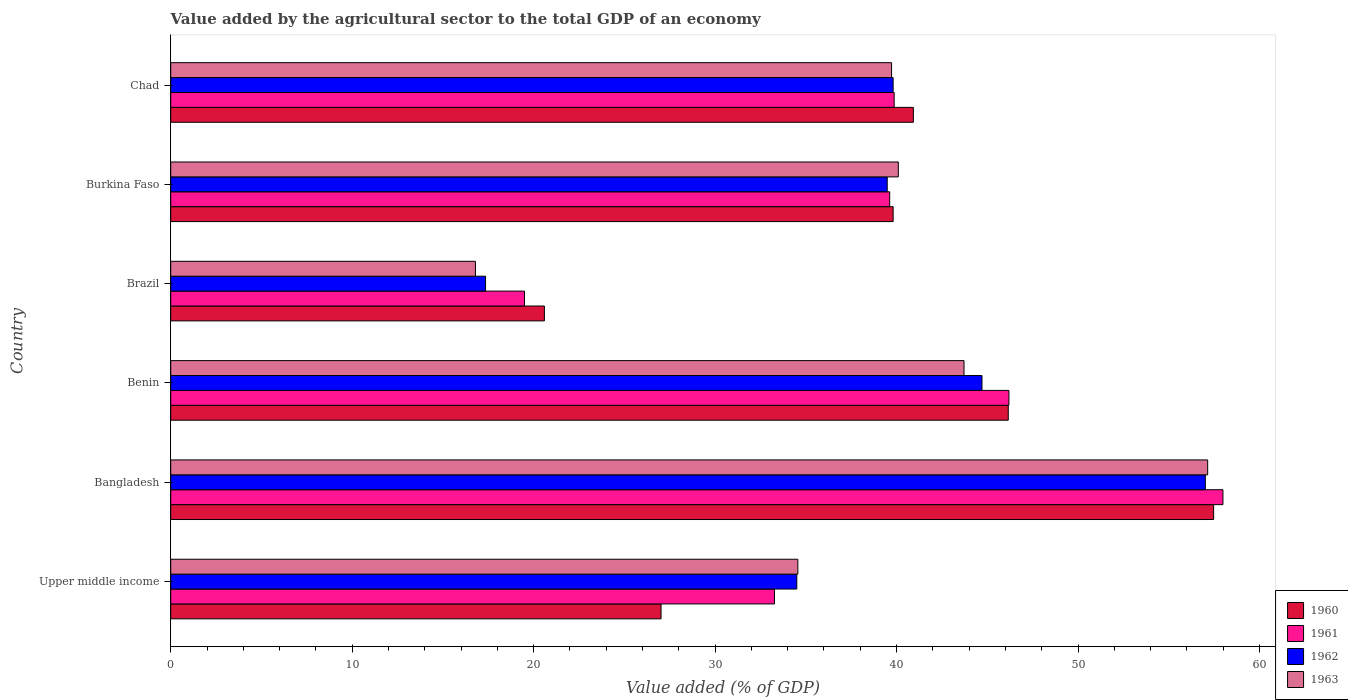How many different coloured bars are there?
Give a very brief answer. 4. How many groups of bars are there?
Your response must be concise. 6. Are the number of bars on each tick of the Y-axis equal?
Your answer should be compact. Yes. How many bars are there on the 5th tick from the top?
Offer a terse response. 4. What is the label of the 2nd group of bars from the top?
Ensure brevity in your answer.  Burkina Faso. What is the value added by the agricultural sector to the total GDP in 1963 in Brazil?
Ensure brevity in your answer.  16.79. Across all countries, what is the maximum value added by the agricultural sector to the total GDP in 1961?
Provide a short and direct response. 57.99. Across all countries, what is the minimum value added by the agricultural sector to the total GDP in 1962?
Offer a very short reply. 17.35. What is the total value added by the agricultural sector to the total GDP in 1961 in the graph?
Provide a short and direct response. 236.44. What is the difference between the value added by the agricultural sector to the total GDP in 1960 in Bangladesh and that in Brazil?
Make the answer very short. 36.88. What is the difference between the value added by the agricultural sector to the total GDP in 1960 in Chad and the value added by the agricultural sector to the total GDP in 1961 in Upper middle income?
Ensure brevity in your answer.  7.65. What is the average value added by the agricultural sector to the total GDP in 1962 per country?
Give a very brief answer. 38.81. What is the difference between the value added by the agricultural sector to the total GDP in 1960 and value added by the agricultural sector to the total GDP in 1962 in Upper middle income?
Make the answer very short. -7.48. What is the ratio of the value added by the agricultural sector to the total GDP in 1961 in Bangladesh to that in Upper middle income?
Offer a very short reply. 1.74. What is the difference between the highest and the second highest value added by the agricultural sector to the total GDP in 1962?
Your answer should be very brief. 12.31. What is the difference between the highest and the lowest value added by the agricultural sector to the total GDP in 1961?
Ensure brevity in your answer.  38.49. Is it the case that in every country, the sum of the value added by the agricultural sector to the total GDP in 1963 and value added by the agricultural sector to the total GDP in 1960 is greater than the sum of value added by the agricultural sector to the total GDP in 1962 and value added by the agricultural sector to the total GDP in 1961?
Provide a succinct answer. No. What does the 2nd bar from the bottom in Bangladesh represents?
Offer a terse response. 1961. Are all the bars in the graph horizontal?
Give a very brief answer. Yes. How many countries are there in the graph?
Your response must be concise. 6. Are the values on the major ticks of X-axis written in scientific E-notation?
Give a very brief answer. No. Does the graph contain grids?
Provide a short and direct response. No. How many legend labels are there?
Ensure brevity in your answer.  4. How are the legend labels stacked?
Provide a succinct answer. Vertical. What is the title of the graph?
Your answer should be very brief. Value added by the agricultural sector to the total GDP of an economy. Does "1970" appear as one of the legend labels in the graph?
Offer a terse response. No. What is the label or title of the X-axis?
Make the answer very short. Value added (% of GDP). What is the label or title of the Y-axis?
Your answer should be very brief. Country. What is the Value added (% of GDP) of 1960 in Upper middle income?
Your response must be concise. 27.02. What is the Value added (% of GDP) of 1961 in Upper middle income?
Provide a succinct answer. 33.27. What is the Value added (% of GDP) in 1962 in Upper middle income?
Ensure brevity in your answer.  34.5. What is the Value added (% of GDP) in 1963 in Upper middle income?
Offer a terse response. 34.56. What is the Value added (% of GDP) of 1960 in Bangladesh?
Give a very brief answer. 57.47. What is the Value added (% of GDP) of 1961 in Bangladesh?
Provide a succinct answer. 57.99. What is the Value added (% of GDP) in 1962 in Bangladesh?
Ensure brevity in your answer.  57.02. What is the Value added (% of GDP) in 1963 in Bangladesh?
Make the answer very short. 57.15. What is the Value added (% of GDP) in 1960 in Benin?
Provide a succinct answer. 46.16. What is the Value added (% of GDP) of 1961 in Benin?
Provide a succinct answer. 46.19. What is the Value added (% of GDP) in 1962 in Benin?
Your answer should be compact. 44.71. What is the Value added (% of GDP) of 1963 in Benin?
Provide a short and direct response. 43.72. What is the Value added (% of GDP) of 1960 in Brazil?
Give a very brief answer. 20.59. What is the Value added (% of GDP) of 1961 in Brazil?
Make the answer very short. 19.5. What is the Value added (% of GDP) in 1962 in Brazil?
Ensure brevity in your answer.  17.35. What is the Value added (% of GDP) in 1963 in Brazil?
Your answer should be compact. 16.79. What is the Value added (% of GDP) of 1960 in Burkina Faso?
Ensure brevity in your answer.  39.81. What is the Value added (% of GDP) in 1961 in Burkina Faso?
Your answer should be very brief. 39.62. What is the Value added (% of GDP) in 1962 in Burkina Faso?
Offer a very short reply. 39.49. What is the Value added (% of GDP) of 1963 in Burkina Faso?
Offer a very short reply. 40.1. What is the Value added (% of GDP) of 1960 in Chad?
Provide a short and direct response. 40.93. What is the Value added (% of GDP) in 1961 in Chad?
Provide a short and direct response. 39.87. What is the Value added (% of GDP) in 1962 in Chad?
Provide a succinct answer. 39.81. What is the Value added (% of GDP) in 1963 in Chad?
Offer a terse response. 39.73. Across all countries, what is the maximum Value added (% of GDP) in 1960?
Offer a very short reply. 57.47. Across all countries, what is the maximum Value added (% of GDP) in 1961?
Keep it short and to the point. 57.99. Across all countries, what is the maximum Value added (% of GDP) of 1962?
Make the answer very short. 57.02. Across all countries, what is the maximum Value added (% of GDP) of 1963?
Offer a terse response. 57.15. Across all countries, what is the minimum Value added (% of GDP) of 1960?
Provide a succinct answer. 20.59. Across all countries, what is the minimum Value added (% of GDP) of 1961?
Provide a short and direct response. 19.5. Across all countries, what is the minimum Value added (% of GDP) of 1962?
Give a very brief answer. 17.35. Across all countries, what is the minimum Value added (% of GDP) in 1963?
Make the answer very short. 16.79. What is the total Value added (% of GDP) of 1960 in the graph?
Make the answer very short. 231.99. What is the total Value added (% of GDP) in 1961 in the graph?
Offer a very short reply. 236.44. What is the total Value added (% of GDP) in 1962 in the graph?
Keep it short and to the point. 232.88. What is the total Value added (% of GDP) of 1963 in the graph?
Your response must be concise. 232.04. What is the difference between the Value added (% of GDP) in 1960 in Upper middle income and that in Bangladesh?
Ensure brevity in your answer.  -30.45. What is the difference between the Value added (% of GDP) in 1961 in Upper middle income and that in Bangladesh?
Your answer should be very brief. -24.71. What is the difference between the Value added (% of GDP) in 1962 in Upper middle income and that in Bangladesh?
Ensure brevity in your answer.  -22.51. What is the difference between the Value added (% of GDP) of 1963 in Upper middle income and that in Bangladesh?
Offer a terse response. -22.59. What is the difference between the Value added (% of GDP) of 1960 in Upper middle income and that in Benin?
Provide a short and direct response. -19.14. What is the difference between the Value added (% of GDP) in 1961 in Upper middle income and that in Benin?
Your answer should be very brief. -12.92. What is the difference between the Value added (% of GDP) in 1962 in Upper middle income and that in Benin?
Your answer should be compact. -10.21. What is the difference between the Value added (% of GDP) in 1963 in Upper middle income and that in Benin?
Your response must be concise. -9.16. What is the difference between the Value added (% of GDP) in 1960 in Upper middle income and that in Brazil?
Ensure brevity in your answer.  6.43. What is the difference between the Value added (% of GDP) of 1961 in Upper middle income and that in Brazil?
Ensure brevity in your answer.  13.78. What is the difference between the Value added (% of GDP) of 1962 in Upper middle income and that in Brazil?
Your response must be concise. 17.15. What is the difference between the Value added (% of GDP) of 1963 in Upper middle income and that in Brazil?
Offer a very short reply. 17.77. What is the difference between the Value added (% of GDP) in 1960 in Upper middle income and that in Burkina Faso?
Provide a succinct answer. -12.79. What is the difference between the Value added (% of GDP) in 1961 in Upper middle income and that in Burkina Faso?
Provide a short and direct response. -6.35. What is the difference between the Value added (% of GDP) in 1962 in Upper middle income and that in Burkina Faso?
Your answer should be very brief. -4.98. What is the difference between the Value added (% of GDP) of 1963 in Upper middle income and that in Burkina Faso?
Make the answer very short. -5.54. What is the difference between the Value added (% of GDP) in 1960 in Upper middle income and that in Chad?
Provide a succinct answer. -13.9. What is the difference between the Value added (% of GDP) of 1961 in Upper middle income and that in Chad?
Offer a very short reply. -6.59. What is the difference between the Value added (% of GDP) in 1962 in Upper middle income and that in Chad?
Ensure brevity in your answer.  -5.31. What is the difference between the Value added (% of GDP) in 1963 in Upper middle income and that in Chad?
Provide a short and direct response. -5.17. What is the difference between the Value added (% of GDP) of 1960 in Bangladesh and that in Benin?
Give a very brief answer. 11.32. What is the difference between the Value added (% of GDP) in 1961 in Bangladesh and that in Benin?
Ensure brevity in your answer.  11.79. What is the difference between the Value added (% of GDP) in 1962 in Bangladesh and that in Benin?
Offer a very short reply. 12.31. What is the difference between the Value added (% of GDP) of 1963 in Bangladesh and that in Benin?
Provide a succinct answer. 13.43. What is the difference between the Value added (% of GDP) of 1960 in Bangladesh and that in Brazil?
Provide a short and direct response. 36.88. What is the difference between the Value added (% of GDP) of 1961 in Bangladesh and that in Brazil?
Your answer should be very brief. 38.49. What is the difference between the Value added (% of GDP) in 1962 in Bangladesh and that in Brazil?
Keep it short and to the point. 39.67. What is the difference between the Value added (% of GDP) in 1963 in Bangladesh and that in Brazil?
Offer a very short reply. 40.35. What is the difference between the Value added (% of GDP) in 1960 in Bangladesh and that in Burkina Faso?
Your answer should be compact. 17.66. What is the difference between the Value added (% of GDP) in 1961 in Bangladesh and that in Burkina Faso?
Ensure brevity in your answer.  18.37. What is the difference between the Value added (% of GDP) of 1962 in Bangladesh and that in Burkina Faso?
Your answer should be compact. 17.53. What is the difference between the Value added (% of GDP) in 1963 in Bangladesh and that in Burkina Faso?
Your answer should be very brief. 17.05. What is the difference between the Value added (% of GDP) in 1960 in Bangladesh and that in Chad?
Keep it short and to the point. 16.55. What is the difference between the Value added (% of GDP) of 1961 in Bangladesh and that in Chad?
Keep it short and to the point. 18.12. What is the difference between the Value added (% of GDP) in 1962 in Bangladesh and that in Chad?
Keep it short and to the point. 17.21. What is the difference between the Value added (% of GDP) of 1963 in Bangladesh and that in Chad?
Offer a terse response. 17.42. What is the difference between the Value added (% of GDP) of 1960 in Benin and that in Brazil?
Ensure brevity in your answer.  25.56. What is the difference between the Value added (% of GDP) of 1961 in Benin and that in Brazil?
Your response must be concise. 26.7. What is the difference between the Value added (% of GDP) in 1962 in Benin and that in Brazil?
Offer a very short reply. 27.36. What is the difference between the Value added (% of GDP) of 1963 in Benin and that in Brazil?
Your response must be concise. 26.92. What is the difference between the Value added (% of GDP) in 1960 in Benin and that in Burkina Faso?
Your answer should be compact. 6.35. What is the difference between the Value added (% of GDP) of 1961 in Benin and that in Burkina Faso?
Offer a very short reply. 6.57. What is the difference between the Value added (% of GDP) of 1962 in Benin and that in Burkina Faso?
Make the answer very short. 5.22. What is the difference between the Value added (% of GDP) of 1963 in Benin and that in Burkina Faso?
Your answer should be very brief. 3.62. What is the difference between the Value added (% of GDP) in 1960 in Benin and that in Chad?
Offer a terse response. 5.23. What is the difference between the Value added (% of GDP) of 1961 in Benin and that in Chad?
Keep it short and to the point. 6.33. What is the difference between the Value added (% of GDP) in 1962 in Benin and that in Chad?
Provide a short and direct response. 4.9. What is the difference between the Value added (% of GDP) of 1963 in Benin and that in Chad?
Provide a short and direct response. 3.99. What is the difference between the Value added (% of GDP) in 1960 in Brazil and that in Burkina Faso?
Your answer should be very brief. -19.22. What is the difference between the Value added (% of GDP) of 1961 in Brazil and that in Burkina Faso?
Provide a succinct answer. -20.13. What is the difference between the Value added (% of GDP) in 1962 in Brazil and that in Burkina Faso?
Give a very brief answer. -22.14. What is the difference between the Value added (% of GDP) of 1963 in Brazil and that in Burkina Faso?
Give a very brief answer. -23.3. What is the difference between the Value added (% of GDP) of 1960 in Brazil and that in Chad?
Offer a very short reply. -20.33. What is the difference between the Value added (% of GDP) in 1961 in Brazil and that in Chad?
Provide a short and direct response. -20.37. What is the difference between the Value added (% of GDP) in 1962 in Brazil and that in Chad?
Offer a very short reply. -22.46. What is the difference between the Value added (% of GDP) of 1963 in Brazil and that in Chad?
Give a very brief answer. -22.93. What is the difference between the Value added (% of GDP) in 1960 in Burkina Faso and that in Chad?
Provide a short and direct response. -1.11. What is the difference between the Value added (% of GDP) of 1961 in Burkina Faso and that in Chad?
Your answer should be very brief. -0.25. What is the difference between the Value added (% of GDP) of 1962 in Burkina Faso and that in Chad?
Ensure brevity in your answer.  -0.33. What is the difference between the Value added (% of GDP) in 1963 in Burkina Faso and that in Chad?
Ensure brevity in your answer.  0.37. What is the difference between the Value added (% of GDP) in 1960 in Upper middle income and the Value added (% of GDP) in 1961 in Bangladesh?
Offer a very short reply. -30.97. What is the difference between the Value added (% of GDP) in 1960 in Upper middle income and the Value added (% of GDP) in 1962 in Bangladesh?
Make the answer very short. -30. What is the difference between the Value added (% of GDP) in 1960 in Upper middle income and the Value added (% of GDP) in 1963 in Bangladesh?
Your response must be concise. -30.12. What is the difference between the Value added (% of GDP) in 1961 in Upper middle income and the Value added (% of GDP) in 1962 in Bangladesh?
Keep it short and to the point. -23.74. What is the difference between the Value added (% of GDP) in 1961 in Upper middle income and the Value added (% of GDP) in 1963 in Bangladesh?
Your response must be concise. -23.87. What is the difference between the Value added (% of GDP) of 1962 in Upper middle income and the Value added (% of GDP) of 1963 in Bangladesh?
Provide a succinct answer. -22.64. What is the difference between the Value added (% of GDP) of 1960 in Upper middle income and the Value added (% of GDP) of 1961 in Benin?
Your response must be concise. -19.17. What is the difference between the Value added (% of GDP) of 1960 in Upper middle income and the Value added (% of GDP) of 1962 in Benin?
Your response must be concise. -17.69. What is the difference between the Value added (% of GDP) in 1960 in Upper middle income and the Value added (% of GDP) in 1963 in Benin?
Your answer should be compact. -16.7. What is the difference between the Value added (% of GDP) of 1961 in Upper middle income and the Value added (% of GDP) of 1962 in Benin?
Offer a very short reply. -11.43. What is the difference between the Value added (% of GDP) in 1961 in Upper middle income and the Value added (% of GDP) in 1963 in Benin?
Provide a short and direct response. -10.44. What is the difference between the Value added (% of GDP) in 1962 in Upper middle income and the Value added (% of GDP) in 1963 in Benin?
Give a very brief answer. -9.21. What is the difference between the Value added (% of GDP) in 1960 in Upper middle income and the Value added (% of GDP) in 1961 in Brazil?
Provide a succinct answer. 7.53. What is the difference between the Value added (% of GDP) of 1960 in Upper middle income and the Value added (% of GDP) of 1962 in Brazil?
Ensure brevity in your answer.  9.67. What is the difference between the Value added (% of GDP) in 1960 in Upper middle income and the Value added (% of GDP) in 1963 in Brazil?
Keep it short and to the point. 10.23. What is the difference between the Value added (% of GDP) of 1961 in Upper middle income and the Value added (% of GDP) of 1962 in Brazil?
Offer a very short reply. 15.92. What is the difference between the Value added (% of GDP) in 1961 in Upper middle income and the Value added (% of GDP) in 1963 in Brazil?
Give a very brief answer. 16.48. What is the difference between the Value added (% of GDP) in 1962 in Upper middle income and the Value added (% of GDP) in 1963 in Brazil?
Give a very brief answer. 17.71. What is the difference between the Value added (% of GDP) of 1960 in Upper middle income and the Value added (% of GDP) of 1961 in Burkina Faso?
Your answer should be very brief. -12.6. What is the difference between the Value added (% of GDP) of 1960 in Upper middle income and the Value added (% of GDP) of 1962 in Burkina Faso?
Provide a short and direct response. -12.46. What is the difference between the Value added (% of GDP) in 1960 in Upper middle income and the Value added (% of GDP) in 1963 in Burkina Faso?
Provide a succinct answer. -13.08. What is the difference between the Value added (% of GDP) in 1961 in Upper middle income and the Value added (% of GDP) in 1962 in Burkina Faso?
Your answer should be very brief. -6.21. What is the difference between the Value added (% of GDP) of 1961 in Upper middle income and the Value added (% of GDP) of 1963 in Burkina Faso?
Give a very brief answer. -6.82. What is the difference between the Value added (% of GDP) of 1962 in Upper middle income and the Value added (% of GDP) of 1963 in Burkina Faso?
Offer a very short reply. -5.59. What is the difference between the Value added (% of GDP) in 1960 in Upper middle income and the Value added (% of GDP) in 1961 in Chad?
Ensure brevity in your answer.  -12.85. What is the difference between the Value added (% of GDP) of 1960 in Upper middle income and the Value added (% of GDP) of 1962 in Chad?
Provide a succinct answer. -12.79. What is the difference between the Value added (% of GDP) in 1960 in Upper middle income and the Value added (% of GDP) in 1963 in Chad?
Provide a short and direct response. -12.7. What is the difference between the Value added (% of GDP) of 1961 in Upper middle income and the Value added (% of GDP) of 1962 in Chad?
Your response must be concise. -6.54. What is the difference between the Value added (% of GDP) of 1961 in Upper middle income and the Value added (% of GDP) of 1963 in Chad?
Provide a succinct answer. -6.45. What is the difference between the Value added (% of GDP) of 1962 in Upper middle income and the Value added (% of GDP) of 1963 in Chad?
Ensure brevity in your answer.  -5.22. What is the difference between the Value added (% of GDP) of 1960 in Bangladesh and the Value added (% of GDP) of 1961 in Benin?
Offer a terse response. 11.28. What is the difference between the Value added (% of GDP) in 1960 in Bangladesh and the Value added (% of GDP) in 1962 in Benin?
Your response must be concise. 12.77. What is the difference between the Value added (% of GDP) of 1960 in Bangladesh and the Value added (% of GDP) of 1963 in Benin?
Make the answer very short. 13.76. What is the difference between the Value added (% of GDP) of 1961 in Bangladesh and the Value added (% of GDP) of 1962 in Benin?
Your response must be concise. 13.28. What is the difference between the Value added (% of GDP) in 1961 in Bangladesh and the Value added (% of GDP) in 1963 in Benin?
Keep it short and to the point. 14.27. What is the difference between the Value added (% of GDP) in 1962 in Bangladesh and the Value added (% of GDP) in 1963 in Benin?
Offer a terse response. 13.3. What is the difference between the Value added (% of GDP) of 1960 in Bangladesh and the Value added (% of GDP) of 1961 in Brazil?
Give a very brief answer. 37.98. What is the difference between the Value added (% of GDP) of 1960 in Bangladesh and the Value added (% of GDP) of 1962 in Brazil?
Offer a terse response. 40.12. What is the difference between the Value added (% of GDP) in 1960 in Bangladesh and the Value added (% of GDP) in 1963 in Brazil?
Ensure brevity in your answer.  40.68. What is the difference between the Value added (% of GDP) of 1961 in Bangladesh and the Value added (% of GDP) of 1962 in Brazil?
Your response must be concise. 40.64. What is the difference between the Value added (% of GDP) in 1961 in Bangladesh and the Value added (% of GDP) in 1963 in Brazil?
Your response must be concise. 41.19. What is the difference between the Value added (% of GDP) of 1962 in Bangladesh and the Value added (% of GDP) of 1963 in Brazil?
Give a very brief answer. 40.22. What is the difference between the Value added (% of GDP) of 1960 in Bangladesh and the Value added (% of GDP) of 1961 in Burkina Faso?
Your answer should be compact. 17.85. What is the difference between the Value added (% of GDP) in 1960 in Bangladesh and the Value added (% of GDP) in 1962 in Burkina Faso?
Offer a very short reply. 17.99. What is the difference between the Value added (% of GDP) of 1960 in Bangladesh and the Value added (% of GDP) of 1963 in Burkina Faso?
Give a very brief answer. 17.38. What is the difference between the Value added (% of GDP) in 1961 in Bangladesh and the Value added (% of GDP) in 1962 in Burkina Faso?
Offer a very short reply. 18.5. What is the difference between the Value added (% of GDP) in 1961 in Bangladesh and the Value added (% of GDP) in 1963 in Burkina Faso?
Your answer should be very brief. 17.89. What is the difference between the Value added (% of GDP) of 1962 in Bangladesh and the Value added (% of GDP) of 1963 in Burkina Faso?
Make the answer very short. 16.92. What is the difference between the Value added (% of GDP) of 1960 in Bangladesh and the Value added (% of GDP) of 1961 in Chad?
Make the answer very short. 17.61. What is the difference between the Value added (% of GDP) of 1960 in Bangladesh and the Value added (% of GDP) of 1962 in Chad?
Offer a very short reply. 17.66. What is the difference between the Value added (% of GDP) in 1960 in Bangladesh and the Value added (% of GDP) in 1963 in Chad?
Offer a terse response. 17.75. What is the difference between the Value added (% of GDP) in 1961 in Bangladesh and the Value added (% of GDP) in 1962 in Chad?
Offer a very short reply. 18.18. What is the difference between the Value added (% of GDP) of 1961 in Bangladesh and the Value added (% of GDP) of 1963 in Chad?
Provide a short and direct response. 18.26. What is the difference between the Value added (% of GDP) in 1962 in Bangladesh and the Value added (% of GDP) in 1963 in Chad?
Make the answer very short. 17.29. What is the difference between the Value added (% of GDP) in 1960 in Benin and the Value added (% of GDP) in 1961 in Brazil?
Offer a terse response. 26.66. What is the difference between the Value added (% of GDP) of 1960 in Benin and the Value added (% of GDP) of 1962 in Brazil?
Provide a succinct answer. 28.81. What is the difference between the Value added (% of GDP) in 1960 in Benin and the Value added (% of GDP) in 1963 in Brazil?
Ensure brevity in your answer.  29.36. What is the difference between the Value added (% of GDP) in 1961 in Benin and the Value added (% of GDP) in 1962 in Brazil?
Offer a terse response. 28.84. What is the difference between the Value added (% of GDP) in 1961 in Benin and the Value added (% of GDP) in 1963 in Brazil?
Offer a very short reply. 29.4. What is the difference between the Value added (% of GDP) in 1962 in Benin and the Value added (% of GDP) in 1963 in Brazil?
Your answer should be very brief. 27.92. What is the difference between the Value added (% of GDP) in 1960 in Benin and the Value added (% of GDP) in 1961 in Burkina Faso?
Your answer should be very brief. 6.54. What is the difference between the Value added (% of GDP) in 1960 in Benin and the Value added (% of GDP) in 1962 in Burkina Faso?
Make the answer very short. 6.67. What is the difference between the Value added (% of GDP) of 1960 in Benin and the Value added (% of GDP) of 1963 in Burkina Faso?
Ensure brevity in your answer.  6.06. What is the difference between the Value added (% of GDP) of 1961 in Benin and the Value added (% of GDP) of 1962 in Burkina Faso?
Provide a succinct answer. 6.71. What is the difference between the Value added (% of GDP) of 1961 in Benin and the Value added (% of GDP) of 1963 in Burkina Faso?
Keep it short and to the point. 6.1. What is the difference between the Value added (% of GDP) of 1962 in Benin and the Value added (% of GDP) of 1963 in Burkina Faso?
Give a very brief answer. 4.61. What is the difference between the Value added (% of GDP) in 1960 in Benin and the Value added (% of GDP) in 1961 in Chad?
Your response must be concise. 6.29. What is the difference between the Value added (% of GDP) in 1960 in Benin and the Value added (% of GDP) in 1962 in Chad?
Your answer should be very brief. 6.35. What is the difference between the Value added (% of GDP) of 1960 in Benin and the Value added (% of GDP) of 1963 in Chad?
Your response must be concise. 6.43. What is the difference between the Value added (% of GDP) in 1961 in Benin and the Value added (% of GDP) in 1962 in Chad?
Your answer should be very brief. 6.38. What is the difference between the Value added (% of GDP) in 1961 in Benin and the Value added (% of GDP) in 1963 in Chad?
Provide a short and direct response. 6.47. What is the difference between the Value added (% of GDP) in 1962 in Benin and the Value added (% of GDP) in 1963 in Chad?
Keep it short and to the point. 4.98. What is the difference between the Value added (% of GDP) in 1960 in Brazil and the Value added (% of GDP) in 1961 in Burkina Faso?
Provide a short and direct response. -19.03. What is the difference between the Value added (% of GDP) of 1960 in Brazil and the Value added (% of GDP) of 1962 in Burkina Faso?
Keep it short and to the point. -18.89. What is the difference between the Value added (% of GDP) of 1960 in Brazil and the Value added (% of GDP) of 1963 in Burkina Faso?
Provide a short and direct response. -19.51. What is the difference between the Value added (% of GDP) of 1961 in Brazil and the Value added (% of GDP) of 1962 in Burkina Faso?
Your answer should be compact. -19.99. What is the difference between the Value added (% of GDP) of 1961 in Brazil and the Value added (% of GDP) of 1963 in Burkina Faso?
Offer a very short reply. -20.6. What is the difference between the Value added (% of GDP) in 1962 in Brazil and the Value added (% of GDP) in 1963 in Burkina Faso?
Provide a succinct answer. -22.75. What is the difference between the Value added (% of GDP) of 1960 in Brazil and the Value added (% of GDP) of 1961 in Chad?
Your response must be concise. -19.28. What is the difference between the Value added (% of GDP) in 1960 in Brazil and the Value added (% of GDP) in 1962 in Chad?
Provide a succinct answer. -19.22. What is the difference between the Value added (% of GDP) of 1960 in Brazil and the Value added (% of GDP) of 1963 in Chad?
Your response must be concise. -19.13. What is the difference between the Value added (% of GDP) in 1961 in Brazil and the Value added (% of GDP) in 1962 in Chad?
Ensure brevity in your answer.  -20.32. What is the difference between the Value added (% of GDP) in 1961 in Brazil and the Value added (% of GDP) in 1963 in Chad?
Your response must be concise. -20.23. What is the difference between the Value added (% of GDP) of 1962 in Brazil and the Value added (% of GDP) of 1963 in Chad?
Provide a succinct answer. -22.38. What is the difference between the Value added (% of GDP) in 1960 in Burkina Faso and the Value added (% of GDP) in 1961 in Chad?
Give a very brief answer. -0.06. What is the difference between the Value added (% of GDP) of 1960 in Burkina Faso and the Value added (% of GDP) of 1963 in Chad?
Give a very brief answer. 0.09. What is the difference between the Value added (% of GDP) of 1961 in Burkina Faso and the Value added (% of GDP) of 1962 in Chad?
Ensure brevity in your answer.  -0.19. What is the difference between the Value added (% of GDP) in 1961 in Burkina Faso and the Value added (% of GDP) in 1963 in Chad?
Provide a succinct answer. -0.1. What is the difference between the Value added (% of GDP) of 1962 in Burkina Faso and the Value added (% of GDP) of 1963 in Chad?
Ensure brevity in your answer.  -0.24. What is the average Value added (% of GDP) of 1960 per country?
Keep it short and to the point. 38.66. What is the average Value added (% of GDP) in 1961 per country?
Provide a short and direct response. 39.41. What is the average Value added (% of GDP) in 1962 per country?
Ensure brevity in your answer.  38.81. What is the average Value added (% of GDP) in 1963 per country?
Provide a short and direct response. 38.67. What is the difference between the Value added (% of GDP) in 1960 and Value added (% of GDP) in 1961 in Upper middle income?
Your answer should be very brief. -6.25. What is the difference between the Value added (% of GDP) of 1960 and Value added (% of GDP) of 1962 in Upper middle income?
Give a very brief answer. -7.48. What is the difference between the Value added (% of GDP) of 1960 and Value added (% of GDP) of 1963 in Upper middle income?
Make the answer very short. -7.54. What is the difference between the Value added (% of GDP) in 1961 and Value added (% of GDP) in 1962 in Upper middle income?
Your answer should be very brief. -1.23. What is the difference between the Value added (% of GDP) in 1961 and Value added (% of GDP) in 1963 in Upper middle income?
Make the answer very short. -1.29. What is the difference between the Value added (% of GDP) in 1962 and Value added (% of GDP) in 1963 in Upper middle income?
Give a very brief answer. -0.06. What is the difference between the Value added (% of GDP) of 1960 and Value added (% of GDP) of 1961 in Bangladesh?
Your answer should be compact. -0.51. What is the difference between the Value added (% of GDP) of 1960 and Value added (% of GDP) of 1962 in Bangladesh?
Your answer should be very brief. 0.46. What is the difference between the Value added (% of GDP) of 1960 and Value added (% of GDP) of 1963 in Bangladesh?
Keep it short and to the point. 0.33. What is the difference between the Value added (% of GDP) in 1961 and Value added (% of GDP) in 1962 in Bangladesh?
Give a very brief answer. 0.97. What is the difference between the Value added (% of GDP) of 1961 and Value added (% of GDP) of 1963 in Bangladesh?
Provide a succinct answer. 0.84. What is the difference between the Value added (% of GDP) of 1962 and Value added (% of GDP) of 1963 in Bangladesh?
Provide a short and direct response. -0.13. What is the difference between the Value added (% of GDP) in 1960 and Value added (% of GDP) in 1961 in Benin?
Make the answer very short. -0.04. What is the difference between the Value added (% of GDP) of 1960 and Value added (% of GDP) of 1962 in Benin?
Your answer should be very brief. 1.45. What is the difference between the Value added (% of GDP) in 1960 and Value added (% of GDP) in 1963 in Benin?
Your response must be concise. 2.44. What is the difference between the Value added (% of GDP) of 1961 and Value added (% of GDP) of 1962 in Benin?
Your answer should be compact. 1.48. What is the difference between the Value added (% of GDP) in 1961 and Value added (% of GDP) in 1963 in Benin?
Make the answer very short. 2.48. What is the difference between the Value added (% of GDP) in 1962 and Value added (% of GDP) in 1963 in Benin?
Keep it short and to the point. 0.99. What is the difference between the Value added (% of GDP) in 1960 and Value added (% of GDP) in 1961 in Brazil?
Your answer should be compact. 1.1. What is the difference between the Value added (% of GDP) of 1960 and Value added (% of GDP) of 1962 in Brazil?
Ensure brevity in your answer.  3.24. What is the difference between the Value added (% of GDP) in 1960 and Value added (% of GDP) in 1963 in Brazil?
Your answer should be very brief. 3.8. What is the difference between the Value added (% of GDP) of 1961 and Value added (% of GDP) of 1962 in Brazil?
Offer a terse response. 2.15. What is the difference between the Value added (% of GDP) in 1961 and Value added (% of GDP) in 1963 in Brazil?
Offer a very short reply. 2.7. What is the difference between the Value added (% of GDP) of 1962 and Value added (% of GDP) of 1963 in Brazil?
Keep it short and to the point. 0.56. What is the difference between the Value added (% of GDP) of 1960 and Value added (% of GDP) of 1961 in Burkina Faso?
Your response must be concise. 0.19. What is the difference between the Value added (% of GDP) of 1960 and Value added (% of GDP) of 1962 in Burkina Faso?
Provide a succinct answer. 0.33. What is the difference between the Value added (% of GDP) in 1960 and Value added (% of GDP) in 1963 in Burkina Faso?
Make the answer very short. -0.29. What is the difference between the Value added (% of GDP) of 1961 and Value added (% of GDP) of 1962 in Burkina Faso?
Offer a terse response. 0.14. What is the difference between the Value added (% of GDP) in 1961 and Value added (% of GDP) in 1963 in Burkina Faso?
Ensure brevity in your answer.  -0.48. What is the difference between the Value added (% of GDP) of 1962 and Value added (% of GDP) of 1963 in Burkina Faso?
Offer a terse response. -0.61. What is the difference between the Value added (% of GDP) of 1960 and Value added (% of GDP) of 1961 in Chad?
Provide a short and direct response. 1.06. What is the difference between the Value added (% of GDP) in 1960 and Value added (% of GDP) in 1962 in Chad?
Offer a very short reply. 1.11. What is the difference between the Value added (% of GDP) in 1960 and Value added (% of GDP) in 1963 in Chad?
Make the answer very short. 1.2. What is the difference between the Value added (% of GDP) in 1961 and Value added (% of GDP) in 1962 in Chad?
Your response must be concise. 0.06. What is the difference between the Value added (% of GDP) in 1961 and Value added (% of GDP) in 1963 in Chad?
Make the answer very short. 0.14. What is the difference between the Value added (% of GDP) of 1962 and Value added (% of GDP) of 1963 in Chad?
Your answer should be very brief. 0.09. What is the ratio of the Value added (% of GDP) in 1960 in Upper middle income to that in Bangladesh?
Give a very brief answer. 0.47. What is the ratio of the Value added (% of GDP) in 1961 in Upper middle income to that in Bangladesh?
Make the answer very short. 0.57. What is the ratio of the Value added (% of GDP) in 1962 in Upper middle income to that in Bangladesh?
Your answer should be very brief. 0.61. What is the ratio of the Value added (% of GDP) of 1963 in Upper middle income to that in Bangladesh?
Provide a succinct answer. 0.6. What is the ratio of the Value added (% of GDP) of 1960 in Upper middle income to that in Benin?
Ensure brevity in your answer.  0.59. What is the ratio of the Value added (% of GDP) in 1961 in Upper middle income to that in Benin?
Provide a short and direct response. 0.72. What is the ratio of the Value added (% of GDP) of 1962 in Upper middle income to that in Benin?
Give a very brief answer. 0.77. What is the ratio of the Value added (% of GDP) in 1963 in Upper middle income to that in Benin?
Provide a short and direct response. 0.79. What is the ratio of the Value added (% of GDP) in 1960 in Upper middle income to that in Brazil?
Your answer should be compact. 1.31. What is the ratio of the Value added (% of GDP) in 1961 in Upper middle income to that in Brazil?
Offer a very short reply. 1.71. What is the ratio of the Value added (% of GDP) of 1962 in Upper middle income to that in Brazil?
Your answer should be compact. 1.99. What is the ratio of the Value added (% of GDP) in 1963 in Upper middle income to that in Brazil?
Your answer should be very brief. 2.06. What is the ratio of the Value added (% of GDP) of 1960 in Upper middle income to that in Burkina Faso?
Make the answer very short. 0.68. What is the ratio of the Value added (% of GDP) of 1961 in Upper middle income to that in Burkina Faso?
Your answer should be very brief. 0.84. What is the ratio of the Value added (% of GDP) of 1962 in Upper middle income to that in Burkina Faso?
Offer a terse response. 0.87. What is the ratio of the Value added (% of GDP) in 1963 in Upper middle income to that in Burkina Faso?
Ensure brevity in your answer.  0.86. What is the ratio of the Value added (% of GDP) of 1960 in Upper middle income to that in Chad?
Provide a succinct answer. 0.66. What is the ratio of the Value added (% of GDP) of 1961 in Upper middle income to that in Chad?
Make the answer very short. 0.83. What is the ratio of the Value added (% of GDP) in 1962 in Upper middle income to that in Chad?
Provide a succinct answer. 0.87. What is the ratio of the Value added (% of GDP) of 1963 in Upper middle income to that in Chad?
Give a very brief answer. 0.87. What is the ratio of the Value added (% of GDP) in 1960 in Bangladesh to that in Benin?
Your answer should be very brief. 1.25. What is the ratio of the Value added (% of GDP) in 1961 in Bangladesh to that in Benin?
Your answer should be compact. 1.26. What is the ratio of the Value added (% of GDP) of 1962 in Bangladesh to that in Benin?
Your answer should be compact. 1.28. What is the ratio of the Value added (% of GDP) in 1963 in Bangladesh to that in Benin?
Your answer should be very brief. 1.31. What is the ratio of the Value added (% of GDP) of 1960 in Bangladesh to that in Brazil?
Your answer should be very brief. 2.79. What is the ratio of the Value added (% of GDP) of 1961 in Bangladesh to that in Brazil?
Ensure brevity in your answer.  2.97. What is the ratio of the Value added (% of GDP) of 1962 in Bangladesh to that in Brazil?
Ensure brevity in your answer.  3.29. What is the ratio of the Value added (% of GDP) in 1963 in Bangladesh to that in Brazil?
Provide a short and direct response. 3.4. What is the ratio of the Value added (% of GDP) of 1960 in Bangladesh to that in Burkina Faso?
Give a very brief answer. 1.44. What is the ratio of the Value added (% of GDP) of 1961 in Bangladesh to that in Burkina Faso?
Your response must be concise. 1.46. What is the ratio of the Value added (% of GDP) of 1962 in Bangladesh to that in Burkina Faso?
Provide a succinct answer. 1.44. What is the ratio of the Value added (% of GDP) in 1963 in Bangladesh to that in Burkina Faso?
Your answer should be compact. 1.43. What is the ratio of the Value added (% of GDP) of 1960 in Bangladesh to that in Chad?
Provide a succinct answer. 1.4. What is the ratio of the Value added (% of GDP) of 1961 in Bangladesh to that in Chad?
Offer a very short reply. 1.45. What is the ratio of the Value added (% of GDP) in 1962 in Bangladesh to that in Chad?
Offer a terse response. 1.43. What is the ratio of the Value added (% of GDP) of 1963 in Bangladesh to that in Chad?
Ensure brevity in your answer.  1.44. What is the ratio of the Value added (% of GDP) of 1960 in Benin to that in Brazil?
Ensure brevity in your answer.  2.24. What is the ratio of the Value added (% of GDP) of 1961 in Benin to that in Brazil?
Your answer should be compact. 2.37. What is the ratio of the Value added (% of GDP) of 1962 in Benin to that in Brazil?
Give a very brief answer. 2.58. What is the ratio of the Value added (% of GDP) of 1963 in Benin to that in Brazil?
Your answer should be very brief. 2.6. What is the ratio of the Value added (% of GDP) in 1960 in Benin to that in Burkina Faso?
Ensure brevity in your answer.  1.16. What is the ratio of the Value added (% of GDP) of 1961 in Benin to that in Burkina Faso?
Keep it short and to the point. 1.17. What is the ratio of the Value added (% of GDP) in 1962 in Benin to that in Burkina Faso?
Your response must be concise. 1.13. What is the ratio of the Value added (% of GDP) of 1963 in Benin to that in Burkina Faso?
Your answer should be very brief. 1.09. What is the ratio of the Value added (% of GDP) of 1960 in Benin to that in Chad?
Your answer should be compact. 1.13. What is the ratio of the Value added (% of GDP) in 1961 in Benin to that in Chad?
Keep it short and to the point. 1.16. What is the ratio of the Value added (% of GDP) in 1962 in Benin to that in Chad?
Ensure brevity in your answer.  1.12. What is the ratio of the Value added (% of GDP) in 1963 in Benin to that in Chad?
Offer a very short reply. 1.1. What is the ratio of the Value added (% of GDP) of 1960 in Brazil to that in Burkina Faso?
Provide a short and direct response. 0.52. What is the ratio of the Value added (% of GDP) in 1961 in Brazil to that in Burkina Faso?
Offer a terse response. 0.49. What is the ratio of the Value added (% of GDP) in 1962 in Brazil to that in Burkina Faso?
Provide a succinct answer. 0.44. What is the ratio of the Value added (% of GDP) of 1963 in Brazil to that in Burkina Faso?
Offer a very short reply. 0.42. What is the ratio of the Value added (% of GDP) of 1960 in Brazil to that in Chad?
Provide a succinct answer. 0.5. What is the ratio of the Value added (% of GDP) of 1961 in Brazil to that in Chad?
Keep it short and to the point. 0.49. What is the ratio of the Value added (% of GDP) in 1962 in Brazil to that in Chad?
Your response must be concise. 0.44. What is the ratio of the Value added (% of GDP) of 1963 in Brazil to that in Chad?
Your answer should be compact. 0.42. What is the ratio of the Value added (% of GDP) of 1960 in Burkina Faso to that in Chad?
Provide a short and direct response. 0.97. What is the ratio of the Value added (% of GDP) in 1961 in Burkina Faso to that in Chad?
Provide a succinct answer. 0.99. What is the ratio of the Value added (% of GDP) of 1963 in Burkina Faso to that in Chad?
Your response must be concise. 1.01. What is the difference between the highest and the second highest Value added (% of GDP) in 1960?
Your response must be concise. 11.32. What is the difference between the highest and the second highest Value added (% of GDP) of 1961?
Make the answer very short. 11.79. What is the difference between the highest and the second highest Value added (% of GDP) of 1962?
Provide a succinct answer. 12.31. What is the difference between the highest and the second highest Value added (% of GDP) of 1963?
Provide a short and direct response. 13.43. What is the difference between the highest and the lowest Value added (% of GDP) in 1960?
Offer a very short reply. 36.88. What is the difference between the highest and the lowest Value added (% of GDP) in 1961?
Give a very brief answer. 38.49. What is the difference between the highest and the lowest Value added (% of GDP) of 1962?
Your response must be concise. 39.67. What is the difference between the highest and the lowest Value added (% of GDP) in 1963?
Make the answer very short. 40.35. 